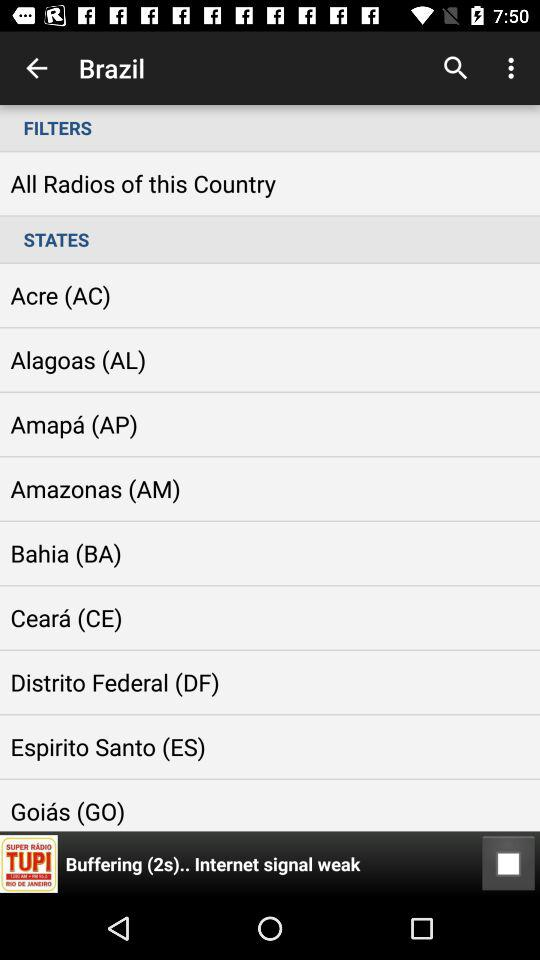Which radio is currently playing?
When the provided information is insufficient, respond with <no answer>. <no answer> 